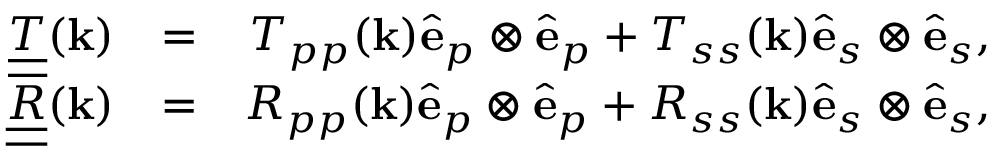Convert formula to latex. <formula><loc_0><loc_0><loc_500><loc_500>\begin{array} { r l r } { \underline { { \underline { T } } } ( { k } ) } & { = } & { T _ { p p } ( { k } ) { \hat { e } } _ { p } \otimes { \hat { e } } _ { p } + T _ { s s } ( { k } ) { \hat { e } } _ { s } \otimes { \hat { e } } _ { s } , } \\ { \underline { { \underline { R } } } ( { k } ) } & { = } & { R _ { p p } ( { k } ) { \hat { e } } _ { p } \otimes { \hat { e } } _ { p } + R _ { s s } ( { k } ) { \hat { e } } _ { s } \otimes { \hat { e } } _ { s } , } \end{array}</formula> 